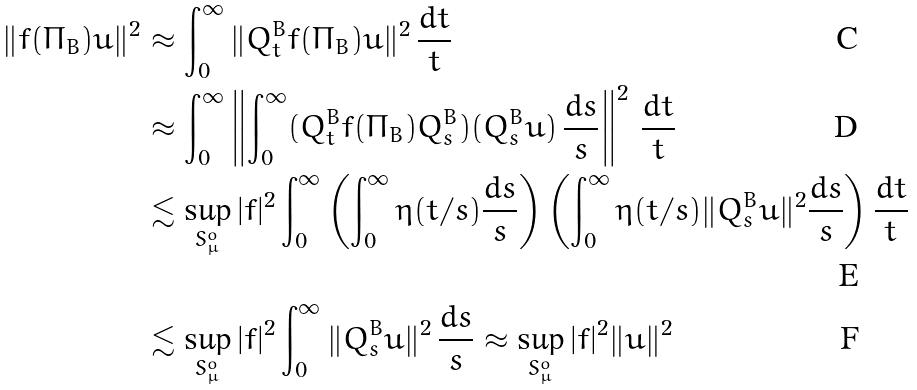Convert formula to latex. <formula><loc_0><loc_0><loc_500><loc_500>\| f ( \Pi _ { B } ) u \| ^ { 2 } & \approx \int _ { 0 } ^ { \infty } \| Q ^ { B } _ { t } f ( \Pi _ { B } ) u \| ^ { 2 } \, \frac { d t } t \\ & \approx \int _ { 0 } ^ { \infty } \left \| \int _ { 0 } ^ { \infty } ( Q ^ { B } _ { t } f ( \Pi _ { B } ) Q ^ { B } _ { s } ) ( Q ^ { B } _ { s } u ) \, \frac { d s } s \right \| ^ { 2 } \, \frac { d t } t \\ & \lesssim \sup _ { S ^ { o } _ { \mu } } | f | ^ { 2 } \int _ { 0 } ^ { \infty } \left ( \int _ { 0 } ^ { \infty } \eta ( t / s ) \frac { d s } s \right ) \left ( \int _ { 0 } ^ { \infty } \eta ( t / s ) \| Q ^ { B } _ { s } u \| ^ { 2 } \frac { d s } s \right ) \frac { d t } { t } \\ & \lesssim \sup _ { S ^ { o } _ { \mu } } | f | ^ { 2 } \int _ { 0 } ^ { \infty } \| Q ^ { B } _ { s } u \| ^ { 2 } \, \frac { d s } s \approx \sup _ { S ^ { o } _ { \mu } } | f | ^ { 2 } \| u \| ^ { 2 }</formula> 